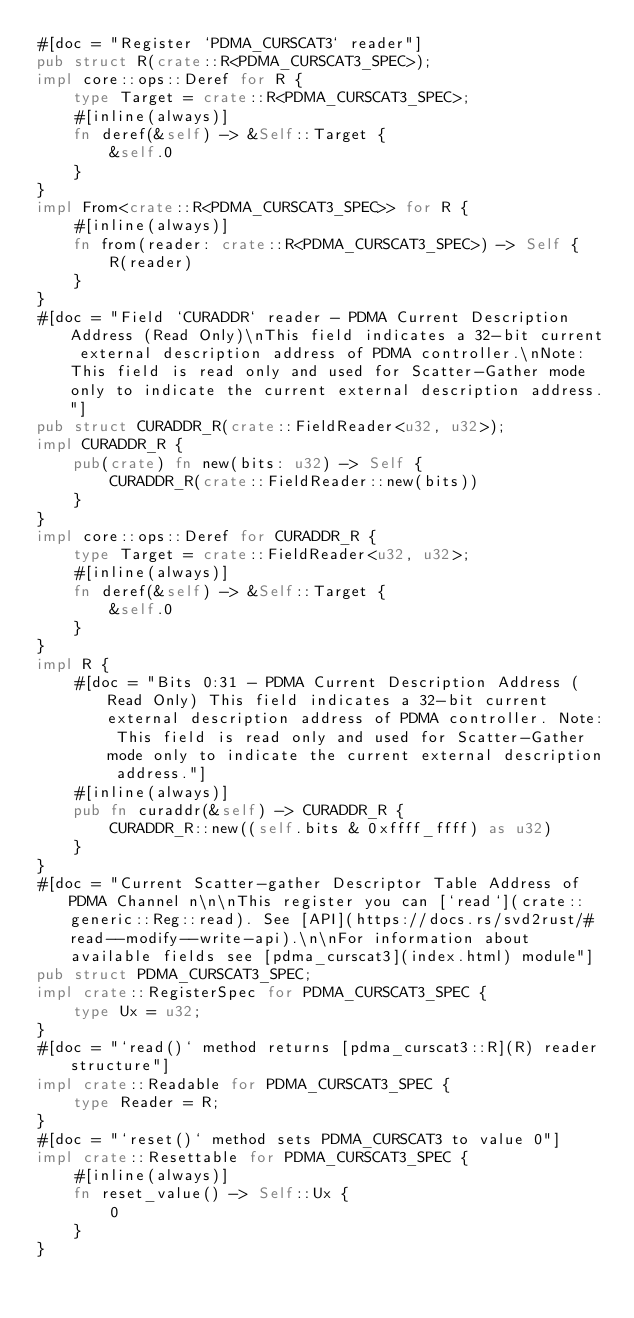Convert code to text. <code><loc_0><loc_0><loc_500><loc_500><_Rust_>#[doc = "Register `PDMA_CURSCAT3` reader"]
pub struct R(crate::R<PDMA_CURSCAT3_SPEC>);
impl core::ops::Deref for R {
    type Target = crate::R<PDMA_CURSCAT3_SPEC>;
    #[inline(always)]
    fn deref(&self) -> &Self::Target {
        &self.0
    }
}
impl From<crate::R<PDMA_CURSCAT3_SPEC>> for R {
    #[inline(always)]
    fn from(reader: crate::R<PDMA_CURSCAT3_SPEC>) -> Self {
        R(reader)
    }
}
#[doc = "Field `CURADDR` reader - PDMA Current Description Address (Read Only)\nThis field indicates a 32-bit current external description address of PDMA controller.\nNote: This field is read only and used for Scatter-Gather mode only to indicate the current external description address."]
pub struct CURADDR_R(crate::FieldReader<u32, u32>);
impl CURADDR_R {
    pub(crate) fn new(bits: u32) -> Self {
        CURADDR_R(crate::FieldReader::new(bits))
    }
}
impl core::ops::Deref for CURADDR_R {
    type Target = crate::FieldReader<u32, u32>;
    #[inline(always)]
    fn deref(&self) -> &Self::Target {
        &self.0
    }
}
impl R {
    #[doc = "Bits 0:31 - PDMA Current Description Address (Read Only) This field indicates a 32-bit current external description address of PDMA controller. Note: This field is read only and used for Scatter-Gather mode only to indicate the current external description address."]
    #[inline(always)]
    pub fn curaddr(&self) -> CURADDR_R {
        CURADDR_R::new((self.bits & 0xffff_ffff) as u32)
    }
}
#[doc = "Current Scatter-gather Descriptor Table Address of PDMA Channel n\n\nThis register you can [`read`](crate::generic::Reg::read). See [API](https://docs.rs/svd2rust/#read--modify--write-api).\n\nFor information about available fields see [pdma_curscat3](index.html) module"]
pub struct PDMA_CURSCAT3_SPEC;
impl crate::RegisterSpec for PDMA_CURSCAT3_SPEC {
    type Ux = u32;
}
#[doc = "`read()` method returns [pdma_curscat3::R](R) reader structure"]
impl crate::Readable for PDMA_CURSCAT3_SPEC {
    type Reader = R;
}
#[doc = "`reset()` method sets PDMA_CURSCAT3 to value 0"]
impl crate::Resettable for PDMA_CURSCAT3_SPEC {
    #[inline(always)]
    fn reset_value() -> Self::Ux {
        0
    }
}
</code> 